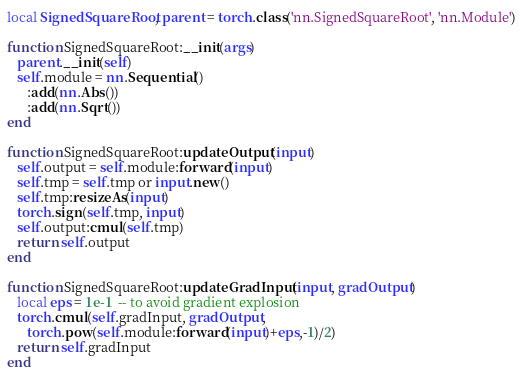Convert code to text. <code><loc_0><loc_0><loc_500><loc_500><_Lua_>local SignedSquareRoot, parent = torch.class('nn.SignedSquareRoot', 'nn.Module')

function SignedSquareRoot:__init(args)
   parent.__init(self)
   self.module = nn.Sequential()
      :add(nn.Abs())
      :add(nn.Sqrt())
end

function SignedSquareRoot:updateOutput(input)
   self.output = self.module:forward(input)
   self.tmp = self.tmp or input.new()
   self.tmp:resizeAs(input)
   torch.sign(self.tmp, input)
   self.output:cmul(self.tmp)
   return self.output
end

function SignedSquareRoot:updateGradInput(input, gradOutput)
   local eps = 1e-1  -- to avoid gradient explosion
   torch.cmul(self.gradInput, gradOutput, 
      torch.pow(self.module:forward(input)+eps,-1)/2)
   return self.gradInput
end</code> 